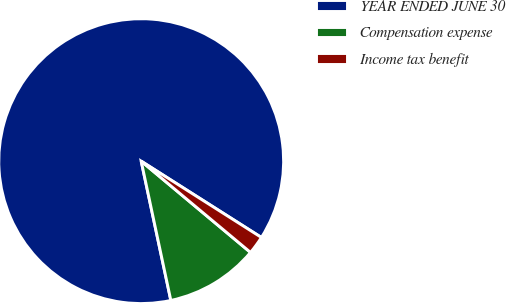Convert chart to OTSL. <chart><loc_0><loc_0><loc_500><loc_500><pie_chart><fcel>YEAR ENDED JUNE 30<fcel>Compensation expense<fcel>Income tax benefit<nl><fcel>87.34%<fcel>10.59%<fcel>2.07%<nl></chart> 